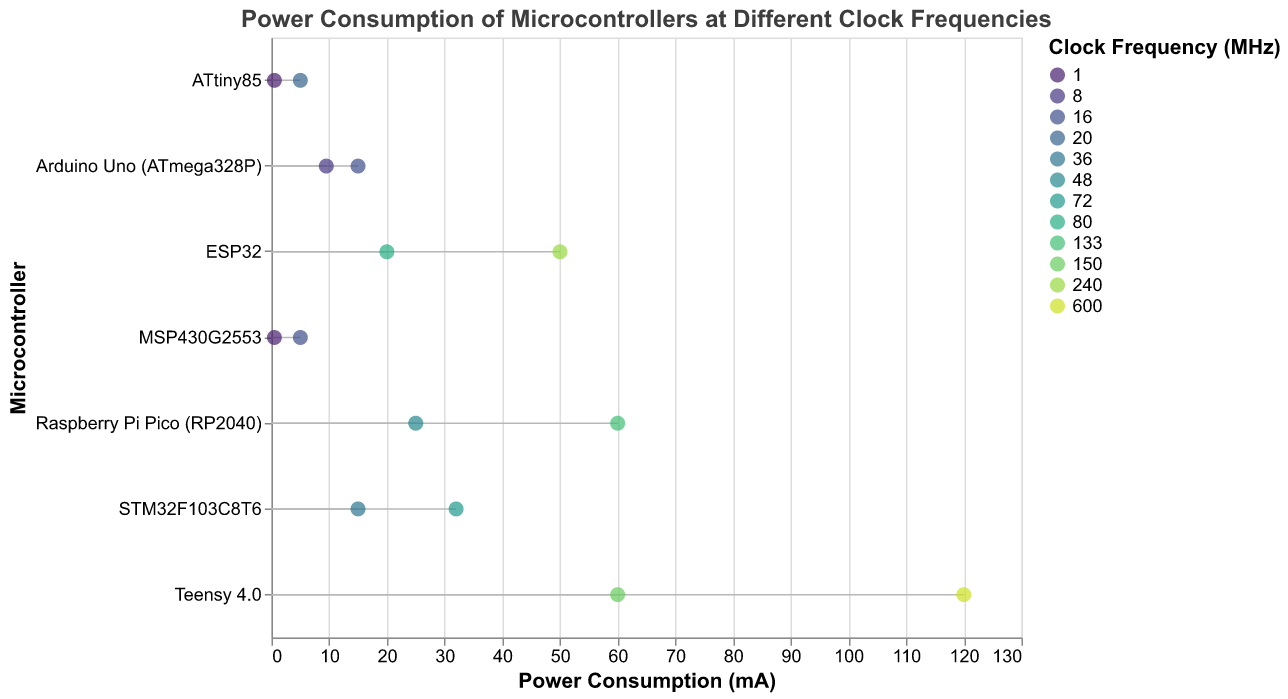What is the title of the plot? The title of the plot is displayed at the top and reads, "Power Consumption of Microcontrollers at Different Clock Frequencies".
Answer: Power Consumption of Microcontrollers at Different Clock Frequencies Which microcontroller has the lowest power consumption at its lowest clock frequency? The plot shows that both the ATtiny85 and the MSP430G2553 have the lowest power consumption at 0.5 mA for their lowest clock frequency of 1 MHz.
Answer: ATtiny85 and MSP430G2553 What are the clock frequencies compared for the Arduino Uno (ATmega328P)? The plot displays two points for the Arduino Uno (ATmega328P), indicating comparisons at 8 MHz and 16 MHz clock frequencies.
Answer: 8 MHz and 16 MHz Which microcontroller shows the highest increase in power consumption when switching from the lowest to the highest clock frequency? The Teensy 4.0 shows the largest increase, going from 60 mA at 150 MHz to 120 mA at 600 MHz.
Answer: Teensy 4.0 What is the difference in power consumption for the STM32F103C8T6 at its two different clock frequencies? From the plot, the STM32F103C8T6 consumes 15 mA at 36 MHz and 32 mA at 72 MHz. The difference is 32 mA - 15 mA = 17 mA.
Answer: 17 mA Which microcontroller has the highest power consumption at any clock frequency? From the highest point in the plot, the Teensy 4.0 at 600 MHz has the highest power consumption at 120 mA.
Answer: Teensy 4.0 at 600 MHz Compare the power consumption of the ESP32 and Raspberry Pi Pico (RP2040) at their highest clock frequencies. The ESP32 consumes 50 mA at 240 MHz, while the Raspberry Pi Pico (RP2040) consumes 60 mA at 133 MHz. The Raspberry Pi Pico consumes more.
Answer: Raspberry Pi Pico (RP2040) consumes more What is the range of power consumption values for the ATtiny85? The plot shows that the ATtiny85 has power consumption values of 0.5 mA at 1 MHz and 5 mA at 20 MHz, giving a range from 0.5 mA to 5 mA.
Answer: 0.5 mA to 5 mA 